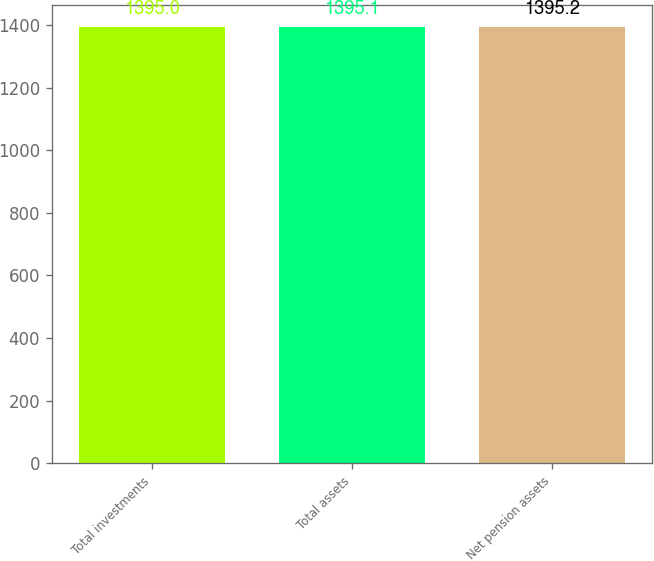Convert chart. <chart><loc_0><loc_0><loc_500><loc_500><bar_chart><fcel>Total investments<fcel>Total assets<fcel>Net pension assets<nl><fcel>1395<fcel>1395.1<fcel>1395.2<nl></chart> 